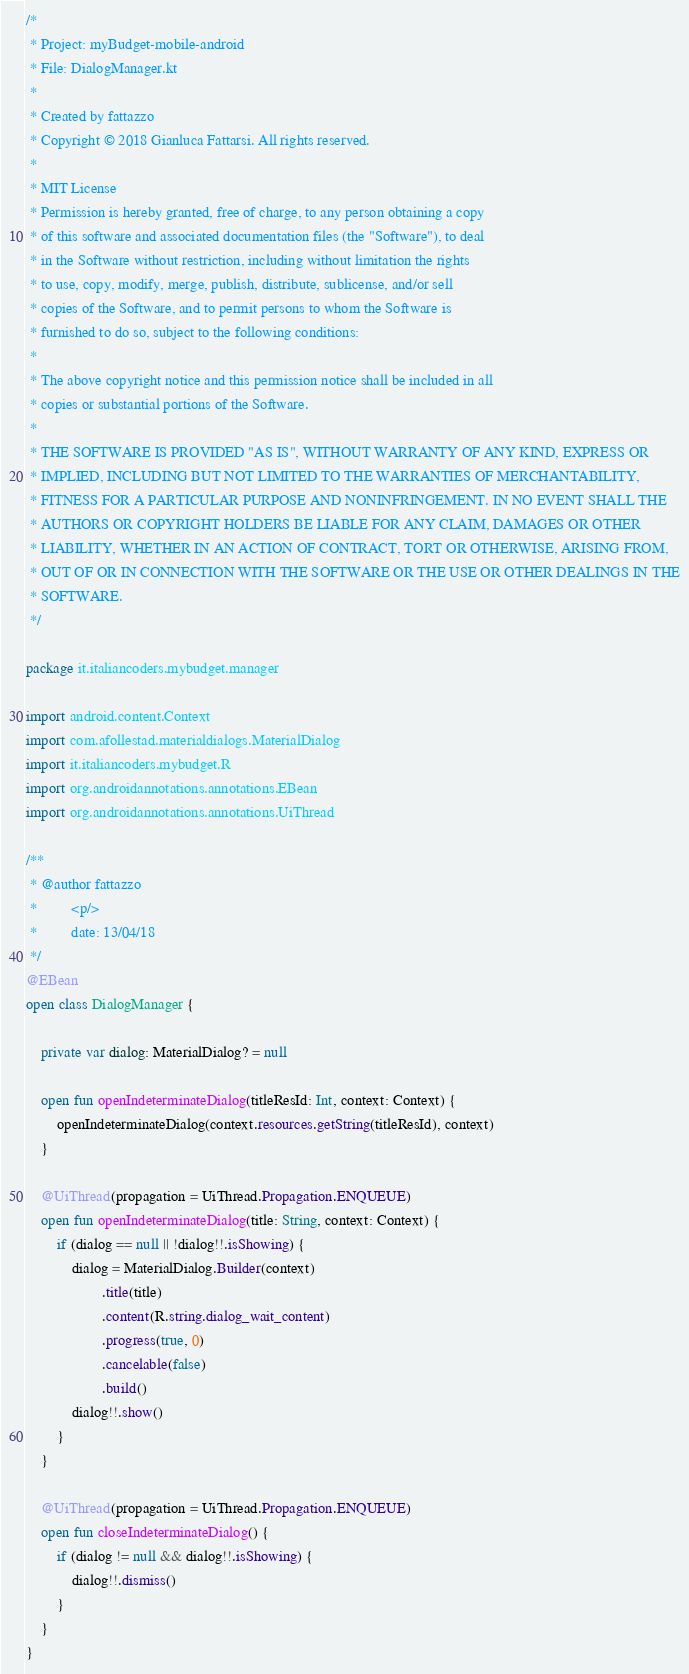Convert code to text. <code><loc_0><loc_0><loc_500><loc_500><_Kotlin_>/*
 * Project: myBudget-mobile-android
 * File: DialogManager.kt
 *
 * Created by fattazzo
 * Copyright © 2018 Gianluca Fattarsi. All rights reserved.
 *
 * MIT License
 * Permission is hereby granted, free of charge, to any person obtaining a copy
 * of this software and associated documentation files (the "Software"), to deal
 * in the Software without restriction, including without limitation the rights
 * to use, copy, modify, merge, publish, distribute, sublicense, and/or sell
 * copies of the Software, and to permit persons to whom the Software is
 * furnished to do so, subject to the following conditions:
 *
 * The above copyright notice and this permission notice shall be included in all
 * copies or substantial portions of the Software.
 *
 * THE SOFTWARE IS PROVIDED "AS IS", WITHOUT WARRANTY OF ANY KIND, EXPRESS OR
 * IMPLIED, INCLUDING BUT NOT LIMITED TO THE WARRANTIES OF MERCHANTABILITY,
 * FITNESS FOR A PARTICULAR PURPOSE AND NONINFRINGEMENT. IN NO EVENT SHALL THE
 * AUTHORS OR COPYRIGHT HOLDERS BE LIABLE FOR ANY CLAIM, DAMAGES OR OTHER
 * LIABILITY, WHETHER IN AN ACTION OF CONTRACT, TORT OR OTHERWISE, ARISING FROM,
 * OUT OF OR IN CONNECTION WITH THE SOFTWARE OR THE USE OR OTHER DEALINGS IN THE
 * SOFTWARE.
 */

package it.italiancoders.mybudget.manager

import android.content.Context
import com.afollestad.materialdialogs.MaterialDialog
import it.italiancoders.mybudget.R
import org.androidannotations.annotations.EBean
import org.androidannotations.annotations.UiThread

/**
 * @author fattazzo
 *         <p/>
 *         date: 13/04/18
 */
@EBean
open class DialogManager {

    private var dialog: MaterialDialog? = null

    open fun openIndeterminateDialog(titleResId: Int, context: Context) {
        openIndeterminateDialog(context.resources.getString(titleResId), context)
    }

    @UiThread(propagation = UiThread.Propagation.ENQUEUE)
    open fun openIndeterminateDialog(title: String, context: Context) {
        if (dialog == null || !dialog!!.isShowing) {
            dialog = MaterialDialog.Builder(context)
                    .title(title)
                    .content(R.string.dialog_wait_content)
                    .progress(true, 0)
                    .cancelable(false)
                    .build()
            dialog!!.show()
        }
    }

    @UiThread(propagation = UiThread.Propagation.ENQUEUE)
    open fun closeIndeterminateDialog() {
        if (dialog != null && dialog!!.isShowing) {
            dialog!!.dismiss()
        }
    }
}</code> 